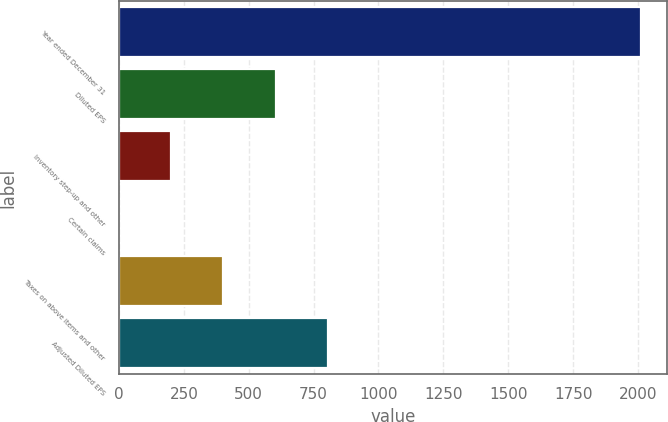Convert chart. <chart><loc_0><loc_0><loc_500><loc_500><bar_chart><fcel>Year ended December 31<fcel>Diluted EPS<fcel>Inventory step-up and other<fcel>Certain claims<fcel>Taxes on above items and other<fcel>Adjusted Diluted EPS<nl><fcel>2013<fcel>604.08<fcel>201.54<fcel>0.27<fcel>402.81<fcel>805.35<nl></chart> 